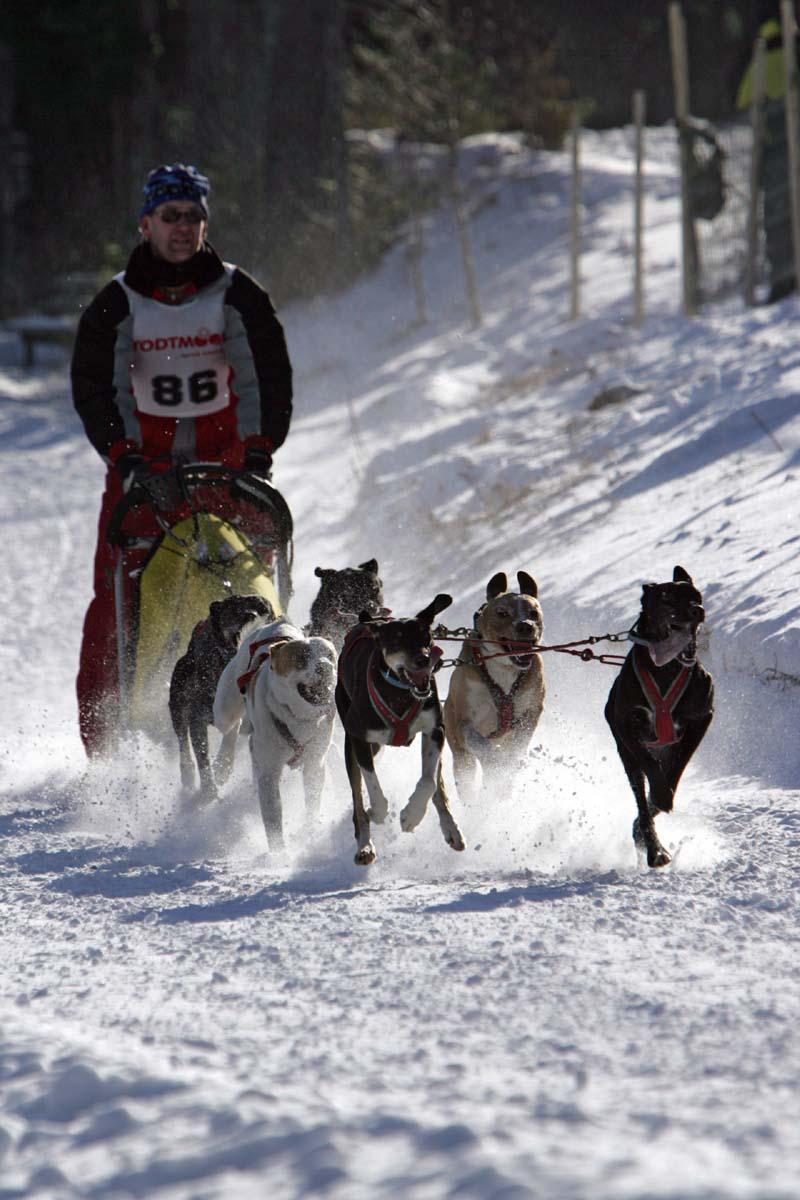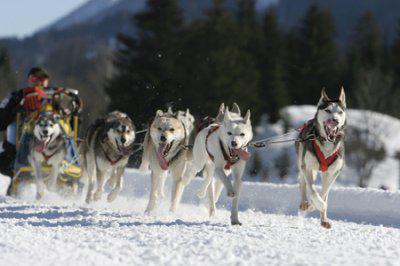The first image is the image on the left, the second image is the image on the right. Considering the images on both sides, is "The dog sled teams in the left and right images move rightward at an angle over the snow and contain traditional husky-type sled dogs." valid? Answer yes or no. Yes. The first image is the image on the left, the second image is the image on the right. Evaluate the accuracy of this statement regarding the images: "The dogs in both pictures are pulling the sled towards the right.". Is it true? Answer yes or no. Yes. 